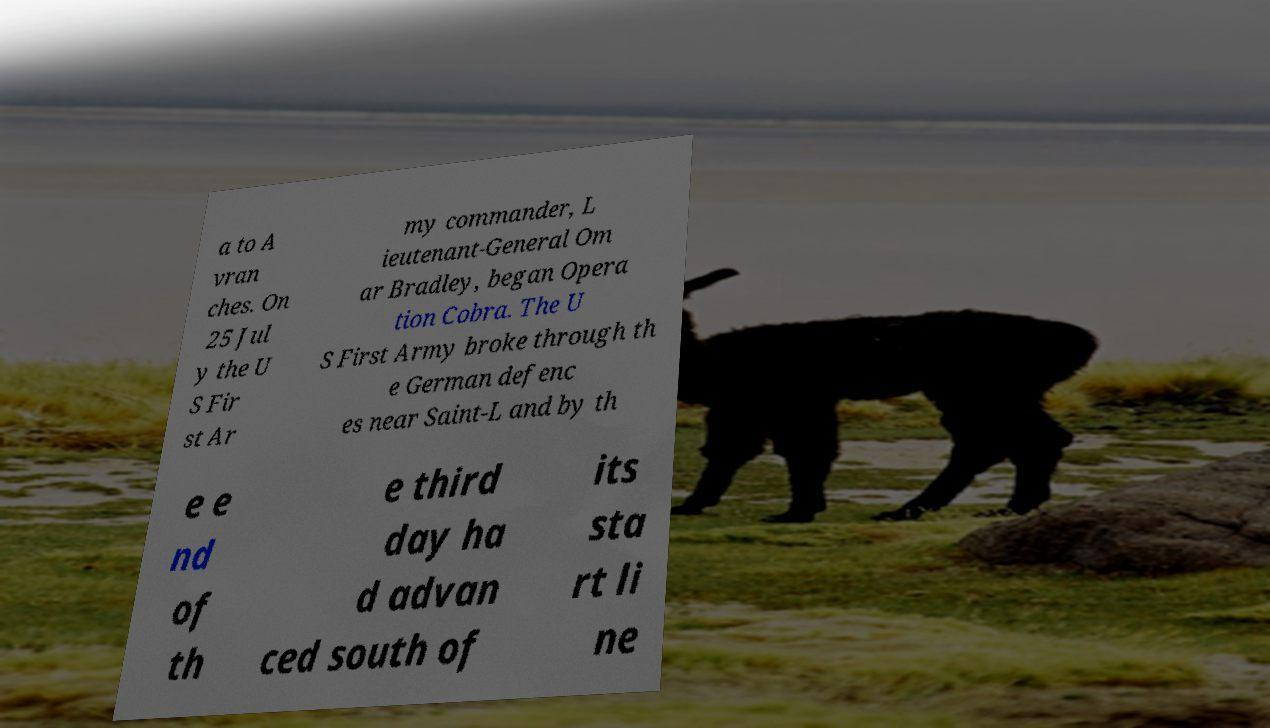Can you read and provide the text displayed in the image?This photo seems to have some interesting text. Can you extract and type it out for me? a to A vran ches. On 25 Jul y the U S Fir st Ar my commander, L ieutenant-General Om ar Bradley, began Opera tion Cobra. The U S First Army broke through th e German defenc es near Saint-L and by th e e nd of th e third day ha d advan ced south of its sta rt li ne 